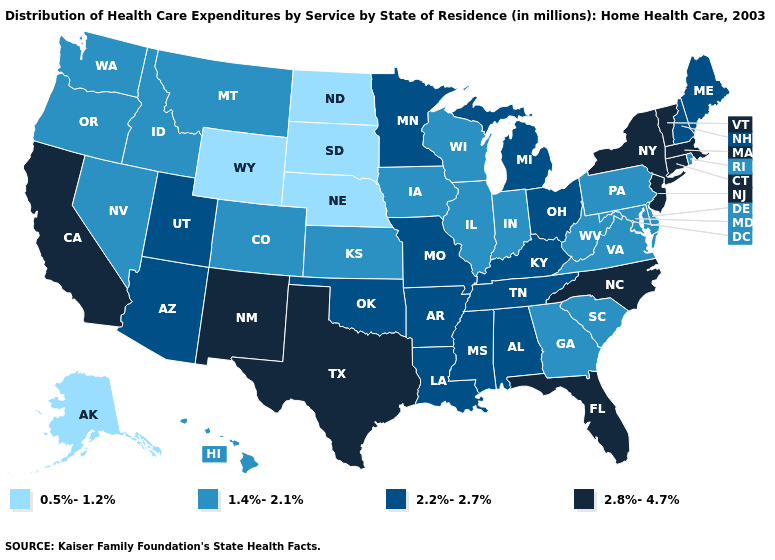Name the states that have a value in the range 2.8%-4.7%?
Be succinct. California, Connecticut, Florida, Massachusetts, New Jersey, New Mexico, New York, North Carolina, Texas, Vermont. What is the value of Nevada?
Short answer required. 1.4%-2.1%. What is the value of North Dakota?
Quick response, please. 0.5%-1.2%. What is the value of Massachusetts?
Keep it brief. 2.8%-4.7%. What is the value of Arkansas?
Short answer required. 2.2%-2.7%. What is the value of Oklahoma?
Be succinct. 2.2%-2.7%. What is the lowest value in the USA?
Write a very short answer. 0.5%-1.2%. How many symbols are there in the legend?
Short answer required. 4. Name the states that have a value in the range 1.4%-2.1%?
Short answer required. Colorado, Delaware, Georgia, Hawaii, Idaho, Illinois, Indiana, Iowa, Kansas, Maryland, Montana, Nevada, Oregon, Pennsylvania, Rhode Island, South Carolina, Virginia, Washington, West Virginia, Wisconsin. Among the states that border Pennsylvania , which have the lowest value?
Keep it brief. Delaware, Maryland, West Virginia. What is the lowest value in the USA?
Write a very short answer. 0.5%-1.2%. Among the states that border Massachusetts , which have the lowest value?
Keep it brief. Rhode Island. What is the highest value in the South ?
Short answer required. 2.8%-4.7%. Does Arkansas have a higher value than Utah?
Concise answer only. No. What is the value of Ohio?
Answer briefly. 2.2%-2.7%. 